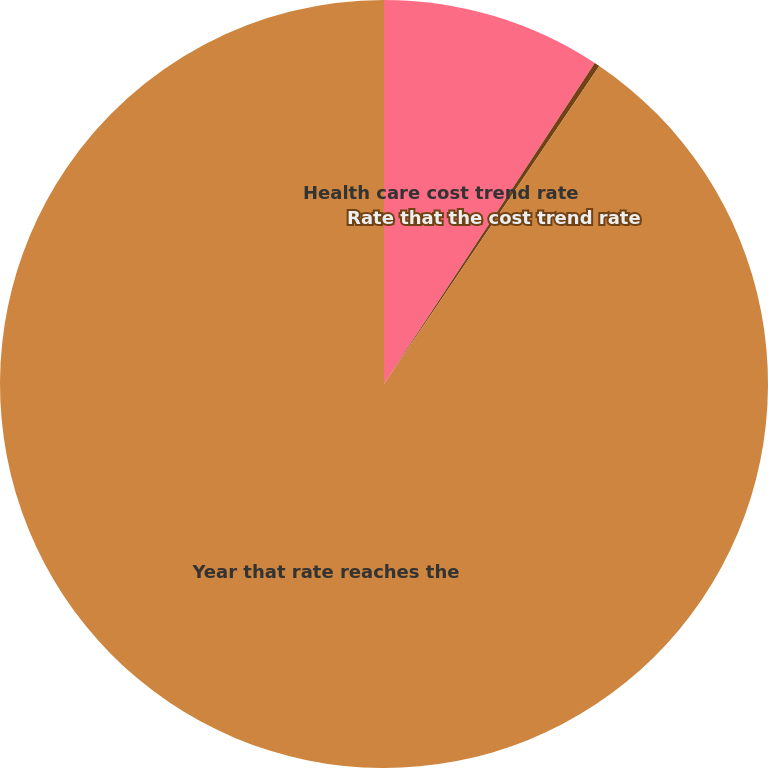<chart> <loc_0><loc_0><loc_500><loc_500><pie_chart><fcel>Health care cost trend rate<fcel>Rate that the cost trend rate<fcel>Year that rate reaches the<nl><fcel>9.25%<fcel>0.22%<fcel>90.52%<nl></chart> 